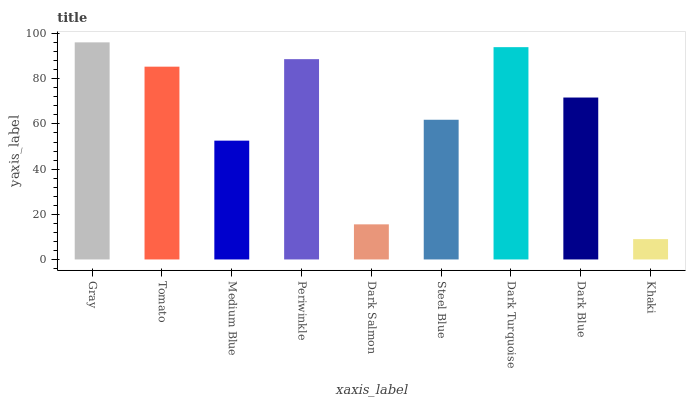Is Khaki the minimum?
Answer yes or no. Yes. Is Gray the maximum?
Answer yes or no. Yes. Is Tomato the minimum?
Answer yes or no. No. Is Tomato the maximum?
Answer yes or no. No. Is Gray greater than Tomato?
Answer yes or no. Yes. Is Tomato less than Gray?
Answer yes or no. Yes. Is Tomato greater than Gray?
Answer yes or no. No. Is Gray less than Tomato?
Answer yes or no. No. Is Dark Blue the high median?
Answer yes or no. Yes. Is Dark Blue the low median?
Answer yes or no. Yes. Is Medium Blue the high median?
Answer yes or no. No. Is Dark Turquoise the low median?
Answer yes or no. No. 